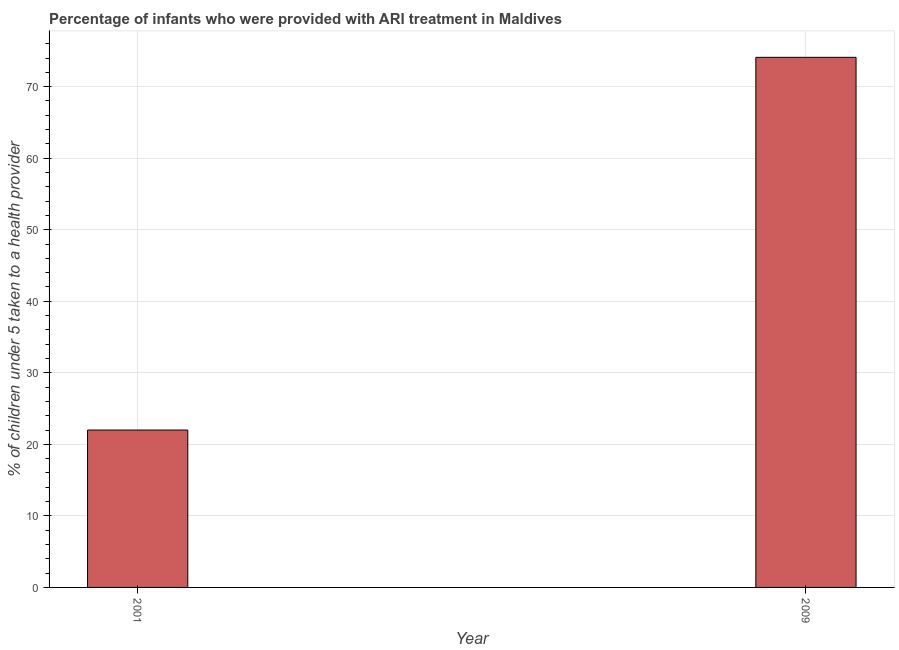What is the title of the graph?
Ensure brevity in your answer.  Percentage of infants who were provided with ARI treatment in Maldives. What is the label or title of the X-axis?
Keep it short and to the point. Year. What is the label or title of the Y-axis?
Provide a short and direct response. % of children under 5 taken to a health provider. What is the percentage of children who were provided with ari treatment in 2009?
Your answer should be very brief. 74.1. Across all years, what is the maximum percentage of children who were provided with ari treatment?
Your answer should be very brief. 74.1. Across all years, what is the minimum percentage of children who were provided with ari treatment?
Your answer should be very brief. 22. In which year was the percentage of children who were provided with ari treatment maximum?
Your answer should be compact. 2009. What is the sum of the percentage of children who were provided with ari treatment?
Your response must be concise. 96.1. What is the difference between the percentage of children who were provided with ari treatment in 2001 and 2009?
Your answer should be compact. -52.1. What is the average percentage of children who were provided with ari treatment per year?
Give a very brief answer. 48.05. What is the median percentage of children who were provided with ari treatment?
Provide a succinct answer. 48.05. Do a majority of the years between 2001 and 2009 (inclusive) have percentage of children who were provided with ari treatment greater than 8 %?
Your answer should be very brief. Yes. What is the ratio of the percentage of children who were provided with ari treatment in 2001 to that in 2009?
Make the answer very short. 0.3. In how many years, is the percentage of children who were provided with ari treatment greater than the average percentage of children who were provided with ari treatment taken over all years?
Your answer should be compact. 1. How many bars are there?
Your answer should be very brief. 2. Are all the bars in the graph horizontal?
Offer a very short reply. No. What is the % of children under 5 taken to a health provider in 2009?
Offer a terse response. 74.1. What is the difference between the % of children under 5 taken to a health provider in 2001 and 2009?
Provide a short and direct response. -52.1. What is the ratio of the % of children under 5 taken to a health provider in 2001 to that in 2009?
Provide a succinct answer. 0.3. 